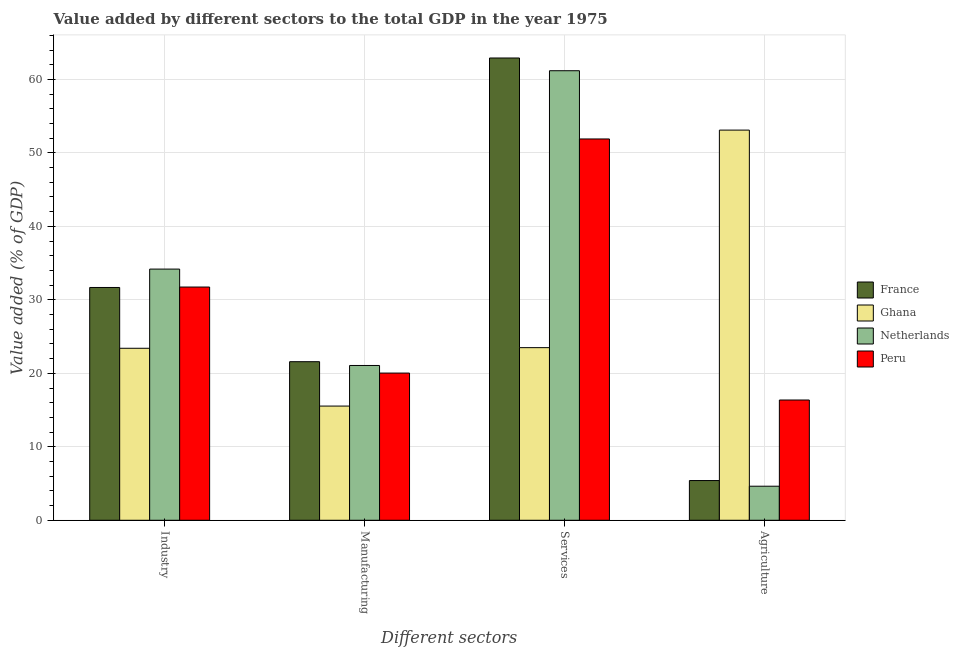How many different coloured bars are there?
Offer a very short reply. 4. Are the number of bars per tick equal to the number of legend labels?
Your response must be concise. Yes. How many bars are there on the 2nd tick from the left?
Provide a short and direct response. 4. How many bars are there on the 3rd tick from the right?
Give a very brief answer. 4. What is the label of the 2nd group of bars from the left?
Ensure brevity in your answer.  Manufacturing. What is the value added by agricultural sector in France?
Your answer should be very brief. 5.4. Across all countries, what is the maximum value added by services sector?
Your answer should be compact. 62.91. Across all countries, what is the minimum value added by services sector?
Provide a succinct answer. 23.49. What is the total value added by agricultural sector in the graph?
Give a very brief answer. 79.51. What is the difference between the value added by industrial sector in France and that in Peru?
Offer a very short reply. -0.06. What is the difference between the value added by services sector in Ghana and the value added by agricultural sector in Netherlands?
Your answer should be very brief. 18.86. What is the average value added by industrial sector per country?
Provide a short and direct response. 30.25. What is the difference between the value added by services sector and value added by manufacturing sector in Ghana?
Offer a terse response. 7.95. In how many countries, is the value added by industrial sector greater than 10 %?
Ensure brevity in your answer.  4. What is the ratio of the value added by manufacturing sector in Netherlands to that in France?
Provide a succinct answer. 0.98. Is the difference between the value added by agricultural sector in Ghana and Netherlands greater than the difference between the value added by services sector in Ghana and Netherlands?
Make the answer very short. Yes. What is the difference between the highest and the second highest value added by services sector?
Provide a succinct answer. 1.73. What is the difference between the highest and the lowest value added by manufacturing sector?
Offer a terse response. 6.04. In how many countries, is the value added by services sector greater than the average value added by services sector taken over all countries?
Your response must be concise. 3. Is the sum of the value added by services sector in France and Netherlands greater than the maximum value added by manufacturing sector across all countries?
Ensure brevity in your answer.  Yes. Are all the bars in the graph horizontal?
Give a very brief answer. No. How many countries are there in the graph?
Provide a succinct answer. 4. Does the graph contain any zero values?
Provide a short and direct response. No. Does the graph contain grids?
Give a very brief answer. Yes. How many legend labels are there?
Keep it short and to the point. 4. What is the title of the graph?
Your answer should be compact. Value added by different sectors to the total GDP in the year 1975. What is the label or title of the X-axis?
Ensure brevity in your answer.  Different sectors. What is the label or title of the Y-axis?
Your answer should be very brief. Value added (% of GDP). What is the Value added (% of GDP) in France in Industry?
Ensure brevity in your answer.  31.68. What is the Value added (% of GDP) of Ghana in Industry?
Provide a succinct answer. 23.41. What is the Value added (% of GDP) of Netherlands in Industry?
Provide a succinct answer. 34.19. What is the Value added (% of GDP) of Peru in Industry?
Ensure brevity in your answer.  31.74. What is the Value added (% of GDP) of France in Manufacturing?
Your response must be concise. 21.58. What is the Value added (% of GDP) of Ghana in Manufacturing?
Offer a terse response. 15.54. What is the Value added (% of GDP) in Netherlands in Manufacturing?
Ensure brevity in your answer.  21.07. What is the Value added (% of GDP) in Peru in Manufacturing?
Provide a succinct answer. 20.03. What is the Value added (% of GDP) in France in Services?
Offer a very short reply. 62.91. What is the Value added (% of GDP) of Ghana in Services?
Provide a succinct answer. 23.49. What is the Value added (% of GDP) of Netherlands in Services?
Your answer should be compact. 61.18. What is the Value added (% of GDP) of Peru in Services?
Ensure brevity in your answer.  51.89. What is the Value added (% of GDP) in France in Agriculture?
Offer a terse response. 5.4. What is the Value added (% of GDP) of Ghana in Agriculture?
Your answer should be compact. 53.1. What is the Value added (% of GDP) of Netherlands in Agriculture?
Keep it short and to the point. 4.63. What is the Value added (% of GDP) of Peru in Agriculture?
Make the answer very short. 16.37. Across all Different sectors, what is the maximum Value added (% of GDP) of France?
Ensure brevity in your answer.  62.91. Across all Different sectors, what is the maximum Value added (% of GDP) of Ghana?
Provide a succinct answer. 53.1. Across all Different sectors, what is the maximum Value added (% of GDP) in Netherlands?
Give a very brief answer. 61.18. Across all Different sectors, what is the maximum Value added (% of GDP) in Peru?
Ensure brevity in your answer.  51.89. Across all Different sectors, what is the minimum Value added (% of GDP) in France?
Provide a short and direct response. 5.4. Across all Different sectors, what is the minimum Value added (% of GDP) in Ghana?
Provide a short and direct response. 15.54. Across all Different sectors, what is the minimum Value added (% of GDP) of Netherlands?
Provide a succinct answer. 4.63. Across all Different sectors, what is the minimum Value added (% of GDP) of Peru?
Ensure brevity in your answer.  16.37. What is the total Value added (% of GDP) in France in the graph?
Give a very brief answer. 121.58. What is the total Value added (% of GDP) in Ghana in the graph?
Keep it short and to the point. 115.54. What is the total Value added (% of GDP) of Netherlands in the graph?
Your response must be concise. 121.07. What is the total Value added (% of GDP) of Peru in the graph?
Offer a very short reply. 120.03. What is the difference between the Value added (% of GDP) in France in Industry and that in Manufacturing?
Provide a succinct answer. 10.1. What is the difference between the Value added (% of GDP) in Ghana in Industry and that in Manufacturing?
Your answer should be very brief. 7.87. What is the difference between the Value added (% of GDP) of Netherlands in Industry and that in Manufacturing?
Your answer should be compact. 13.12. What is the difference between the Value added (% of GDP) of Peru in Industry and that in Manufacturing?
Ensure brevity in your answer.  11.71. What is the difference between the Value added (% of GDP) in France in Industry and that in Services?
Offer a terse response. -31.23. What is the difference between the Value added (% of GDP) in Ghana in Industry and that in Services?
Make the answer very short. -0.08. What is the difference between the Value added (% of GDP) of Netherlands in Industry and that in Services?
Your answer should be very brief. -26.99. What is the difference between the Value added (% of GDP) of Peru in Industry and that in Services?
Provide a short and direct response. -20.15. What is the difference between the Value added (% of GDP) of France in Industry and that in Agriculture?
Your answer should be very brief. 26.28. What is the difference between the Value added (% of GDP) in Ghana in Industry and that in Agriculture?
Your answer should be compact. -29.69. What is the difference between the Value added (% of GDP) in Netherlands in Industry and that in Agriculture?
Your answer should be very brief. 29.55. What is the difference between the Value added (% of GDP) in Peru in Industry and that in Agriculture?
Make the answer very short. 15.37. What is the difference between the Value added (% of GDP) of France in Manufacturing and that in Services?
Give a very brief answer. -41.33. What is the difference between the Value added (% of GDP) in Ghana in Manufacturing and that in Services?
Ensure brevity in your answer.  -7.95. What is the difference between the Value added (% of GDP) in Netherlands in Manufacturing and that in Services?
Offer a terse response. -40.11. What is the difference between the Value added (% of GDP) of Peru in Manufacturing and that in Services?
Give a very brief answer. -31.86. What is the difference between the Value added (% of GDP) of France in Manufacturing and that in Agriculture?
Keep it short and to the point. 16.18. What is the difference between the Value added (% of GDP) of Ghana in Manufacturing and that in Agriculture?
Offer a very short reply. -37.56. What is the difference between the Value added (% of GDP) of Netherlands in Manufacturing and that in Agriculture?
Your answer should be very brief. 16.43. What is the difference between the Value added (% of GDP) in Peru in Manufacturing and that in Agriculture?
Offer a terse response. 3.67. What is the difference between the Value added (% of GDP) in France in Services and that in Agriculture?
Your answer should be very brief. 57.51. What is the difference between the Value added (% of GDP) in Ghana in Services and that in Agriculture?
Provide a short and direct response. -29.61. What is the difference between the Value added (% of GDP) in Netherlands in Services and that in Agriculture?
Your answer should be compact. 56.55. What is the difference between the Value added (% of GDP) in Peru in Services and that in Agriculture?
Make the answer very short. 35.53. What is the difference between the Value added (% of GDP) in France in Industry and the Value added (% of GDP) in Ghana in Manufacturing?
Keep it short and to the point. 16.14. What is the difference between the Value added (% of GDP) in France in Industry and the Value added (% of GDP) in Netherlands in Manufacturing?
Offer a very short reply. 10.62. What is the difference between the Value added (% of GDP) in France in Industry and the Value added (% of GDP) in Peru in Manufacturing?
Provide a short and direct response. 11.65. What is the difference between the Value added (% of GDP) of Ghana in Industry and the Value added (% of GDP) of Netherlands in Manufacturing?
Your response must be concise. 2.34. What is the difference between the Value added (% of GDP) in Ghana in Industry and the Value added (% of GDP) in Peru in Manufacturing?
Keep it short and to the point. 3.37. What is the difference between the Value added (% of GDP) in Netherlands in Industry and the Value added (% of GDP) in Peru in Manufacturing?
Make the answer very short. 14.15. What is the difference between the Value added (% of GDP) in France in Industry and the Value added (% of GDP) in Ghana in Services?
Your answer should be compact. 8.19. What is the difference between the Value added (% of GDP) in France in Industry and the Value added (% of GDP) in Netherlands in Services?
Provide a succinct answer. -29.5. What is the difference between the Value added (% of GDP) in France in Industry and the Value added (% of GDP) in Peru in Services?
Ensure brevity in your answer.  -20.21. What is the difference between the Value added (% of GDP) in Ghana in Industry and the Value added (% of GDP) in Netherlands in Services?
Keep it short and to the point. -37.77. What is the difference between the Value added (% of GDP) of Ghana in Industry and the Value added (% of GDP) of Peru in Services?
Make the answer very short. -28.49. What is the difference between the Value added (% of GDP) of Netherlands in Industry and the Value added (% of GDP) of Peru in Services?
Make the answer very short. -17.71. What is the difference between the Value added (% of GDP) of France in Industry and the Value added (% of GDP) of Ghana in Agriculture?
Your answer should be very brief. -21.42. What is the difference between the Value added (% of GDP) of France in Industry and the Value added (% of GDP) of Netherlands in Agriculture?
Provide a succinct answer. 27.05. What is the difference between the Value added (% of GDP) in France in Industry and the Value added (% of GDP) in Peru in Agriculture?
Provide a succinct answer. 15.32. What is the difference between the Value added (% of GDP) in Ghana in Industry and the Value added (% of GDP) in Netherlands in Agriculture?
Provide a succinct answer. 18.77. What is the difference between the Value added (% of GDP) in Ghana in Industry and the Value added (% of GDP) in Peru in Agriculture?
Give a very brief answer. 7.04. What is the difference between the Value added (% of GDP) of Netherlands in Industry and the Value added (% of GDP) of Peru in Agriculture?
Offer a terse response. 17.82. What is the difference between the Value added (% of GDP) of France in Manufacturing and the Value added (% of GDP) of Ghana in Services?
Offer a very short reply. -1.91. What is the difference between the Value added (% of GDP) of France in Manufacturing and the Value added (% of GDP) of Netherlands in Services?
Provide a short and direct response. -39.6. What is the difference between the Value added (% of GDP) in France in Manufacturing and the Value added (% of GDP) in Peru in Services?
Your answer should be compact. -30.31. What is the difference between the Value added (% of GDP) in Ghana in Manufacturing and the Value added (% of GDP) in Netherlands in Services?
Give a very brief answer. -45.64. What is the difference between the Value added (% of GDP) in Ghana in Manufacturing and the Value added (% of GDP) in Peru in Services?
Offer a terse response. -36.35. What is the difference between the Value added (% of GDP) in Netherlands in Manufacturing and the Value added (% of GDP) in Peru in Services?
Provide a succinct answer. -30.83. What is the difference between the Value added (% of GDP) in France in Manufacturing and the Value added (% of GDP) in Ghana in Agriculture?
Keep it short and to the point. -31.52. What is the difference between the Value added (% of GDP) in France in Manufacturing and the Value added (% of GDP) in Netherlands in Agriculture?
Ensure brevity in your answer.  16.95. What is the difference between the Value added (% of GDP) in France in Manufacturing and the Value added (% of GDP) in Peru in Agriculture?
Keep it short and to the point. 5.21. What is the difference between the Value added (% of GDP) in Ghana in Manufacturing and the Value added (% of GDP) in Netherlands in Agriculture?
Offer a terse response. 10.91. What is the difference between the Value added (% of GDP) in Ghana in Manufacturing and the Value added (% of GDP) in Peru in Agriculture?
Keep it short and to the point. -0.82. What is the difference between the Value added (% of GDP) in Netherlands in Manufacturing and the Value added (% of GDP) in Peru in Agriculture?
Make the answer very short. 4.7. What is the difference between the Value added (% of GDP) in France in Services and the Value added (% of GDP) in Ghana in Agriculture?
Provide a succinct answer. 9.81. What is the difference between the Value added (% of GDP) of France in Services and the Value added (% of GDP) of Netherlands in Agriculture?
Your answer should be very brief. 58.28. What is the difference between the Value added (% of GDP) of France in Services and the Value added (% of GDP) of Peru in Agriculture?
Your answer should be compact. 46.55. What is the difference between the Value added (% of GDP) of Ghana in Services and the Value added (% of GDP) of Netherlands in Agriculture?
Your answer should be very brief. 18.86. What is the difference between the Value added (% of GDP) of Ghana in Services and the Value added (% of GDP) of Peru in Agriculture?
Your response must be concise. 7.13. What is the difference between the Value added (% of GDP) of Netherlands in Services and the Value added (% of GDP) of Peru in Agriculture?
Make the answer very short. 44.81. What is the average Value added (% of GDP) of France per Different sectors?
Ensure brevity in your answer.  30.39. What is the average Value added (% of GDP) in Ghana per Different sectors?
Offer a very short reply. 28.89. What is the average Value added (% of GDP) of Netherlands per Different sectors?
Provide a succinct answer. 30.27. What is the average Value added (% of GDP) in Peru per Different sectors?
Give a very brief answer. 30.01. What is the difference between the Value added (% of GDP) of France and Value added (% of GDP) of Ghana in Industry?
Keep it short and to the point. 8.27. What is the difference between the Value added (% of GDP) of France and Value added (% of GDP) of Netherlands in Industry?
Your answer should be very brief. -2.5. What is the difference between the Value added (% of GDP) in France and Value added (% of GDP) in Peru in Industry?
Your answer should be very brief. -0.06. What is the difference between the Value added (% of GDP) of Ghana and Value added (% of GDP) of Netherlands in Industry?
Give a very brief answer. -10.78. What is the difference between the Value added (% of GDP) of Ghana and Value added (% of GDP) of Peru in Industry?
Provide a succinct answer. -8.33. What is the difference between the Value added (% of GDP) of Netherlands and Value added (% of GDP) of Peru in Industry?
Make the answer very short. 2.44. What is the difference between the Value added (% of GDP) of France and Value added (% of GDP) of Ghana in Manufacturing?
Provide a succinct answer. 6.04. What is the difference between the Value added (% of GDP) of France and Value added (% of GDP) of Netherlands in Manufacturing?
Keep it short and to the point. 0.51. What is the difference between the Value added (% of GDP) of France and Value added (% of GDP) of Peru in Manufacturing?
Offer a terse response. 1.55. What is the difference between the Value added (% of GDP) in Ghana and Value added (% of GDP) in Netherlands in Manufacturing?
Provide a succinct answer. -5.52. What is the difference between the Value added (% of GDP) of Ghana and Value added (% of GDP) of Peru in Manufacturing?
Your answer should be very brief. -4.49. What is the difference between the Value added (% of GDP) of Netherlands and Value added (% of GDP) of Peru in Manufacturing?
Provide a succinct answer. 1.03. What is the difference between the Value added (% of GDP) of France and Value added (% of GDP) of Ghana in Services?
Offer a terse response. 39.42. What is the difference between the Value added (% of GDP) in France and Value added (% of GDP) in Netherlands in Services?
Give a very brief answer. 1.73. What is the difference between the Value added (% of GDP) of France and Value added (% of GDP) of Peru in Services?
Provide a succinct answer. 11.02. What is the difference between the Value added (% of GDP) in Ghana and Value added (% of GDP) in Netherlands in Services?
Keep it short and to the point. -37.69. What is the difference between the Value added (% of GDP) in Ghana and Value added (% of GDP) in Peru in Services?
Give a very brief answer. -28.4. What is the difference between the Value added (% of GDP) in Netherlands and Value added (% of GDP) in Peru in Services?
Keep it short and to the point. 9.29. What is the difference between the Value added (% of GDP) of France and Value added (% of GDP) of Ghana in Agriculture?
Your answer should be very brief. -47.7. What is the difference between the Value added (% of GDP) of France and Value added (% of GDP) of Netherlands in Agriculture?
Make the answer very short. 0.77. What is the difference between the Value added (% of GDP) of France and Value added (% of GDP) of Peru in Agriculture?
Offer a very short reply. -10.96. What is the difference between the Value added (% of GDP) in Ghana and Value added (% of GDP) in Netherlands in Agriculture?
Offer a very short reply. 48.47. What is the difference between the Value added (% of GDP) of Ghana and Value added (% of GDP) of Peru in Agriculture?
Provide a short and direct response. 36.73. What is the difference between the Value added (% of GDP) in Netherlands and Value added (% of GDP) in Peru in Agriculture?
Make the answer very short. -11.73. What is the ratio of the Value added (% of GDP) in France in Industry to that in Manufacturing?
Give a very brief answer. 1.47. What is the ratio of the Value added (% of GDP) of Ghana in Industry to that in Manufacturing?
Give a very brief answer. 1.51. What is the ratio of the Value added (% of GDP) in Netherlands in Industry to that in Manufacturing?
Offer a very short reply. 1.62. What is the ratio of the Value added (% of GDP) in Peru in Industry to that in Manufacturing?
Make the answer very short. 1.58. What is the ratio of the Value added (% of GDP) in France in Industry to that in Services?
Your answer should be compact. 0.5. What is the ratio of the Value added (% of GDP) in Netherlands in Industry to that in Services?
Offer a very short reply. 0.56. What is the ratio of the Value added (% of GDP) in Peru in Industry to that in Services?
Ensure brevity in your answer.  0.61. What is the ratio of the Value added (% of GDP) of France in Industry to that in Agriculture?
Provide a succinct answer. 5.86. What is the ratio of the Value added (% of GDP) of Ghana in Industry to that in Agriculture?
Offer a very short reply. 0.44. What is the ratio of the Value added (% of GDP) of Netherlands in Industry to that in Agriculture?
Offer a terse response. 7.38. What is the ratio of the Value added (% of GDP) of Peru in Industry to that in Agriculture?
Make the answer very short. 1.94. What is the ratio of the Value added (% of GDP) in France in Manufacturing to that in Services?
Give a very brief answer. 0.34. What is the ratio of the Value added (% of GDP) in Ghana in Manufacturing to that in Services?
Make the answer very short. 0.66. What is the ratio of the Value added (% of GDP) in Netherlands in Manufacturing to that in Services?
Keep it short and to the point. 0.34. What is the ratio of the Value added (% of GDP) of Peru in Manufacturing to that in Services?
Offer a terse response. 0.39. What is the ratio of the Value added (% of GDP) of France in Manufacturing to that in Agriculture?
Provide a succinct answer. 3.99. What is the ratio of the Value added (% of GDP) of Ghana in Manufacturing to that in Agriculture?
Ensure brevity in your answer.  0.29. What is the ratio of the Value added (% of GDP) in Netherlands in Manufacturing to that in Agriculture?
Offer a terse response. 4.55. What is the ratio of the Value added (% of GDP) in Peru in Manufacturing to that in Agriculture?
Give a very brief answer. 1.22. What is the ratio of the Value added (% of GDP) in France in Services to that in Agriculture?
Offer a terse response. 11.64. What is the ratio of the Value added (% of GDP) of Ghana in Services to that in Agriculture?
Give a very brief answer. 0.44. What is the ratio of the Value added (% of GDP) in Netherlands in Services to that in Agriculture?
Give a very brief answer. 13.2. What is the ratio of the Value added (% of GDP) in Peru in Services to that in Agriculture?
Your response must be concise. 3.17. What is the difference between the highest and the second highest Value added (% of GDP) in France?
Offer a terse response. 31.23. What is the difference between the highest and the second highest Value added (% of GDP) of Ghana?
Your answer should be compact. 29.61. What is the difference between the highest and the second highest Value added (% of GDP) in Netherlands?
Make the answer very short. 26.99. What is the difference between the highest and the second highest Value added (% of GDP) in Peru?
Ensure brevity in your answer.  20.15. What is the difference between the highest and the lowest Value added (% of GDP) of France?
Ensure brevity in your answer.  57.51. What is the difference between the highest and the lowest Value added (% of GDP) in Ghana?
Give a very brief answer. 37.56. What is the difference between the highest and the lowest Value added (% of GDP) in Netherlands?
Your answer should be compact. 56.55. What is the difference between the highest and the lowest Value added (% of GDP) in Peru?
Your answer should be compact. 35.53. 